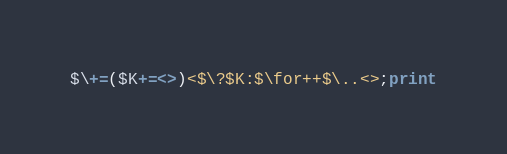<code> <loc_0><loc_0><loc_500><loc_500><_Perl_>$\+=($K+=<>)<$\?$K:$\for++$\..<>;print</code> 